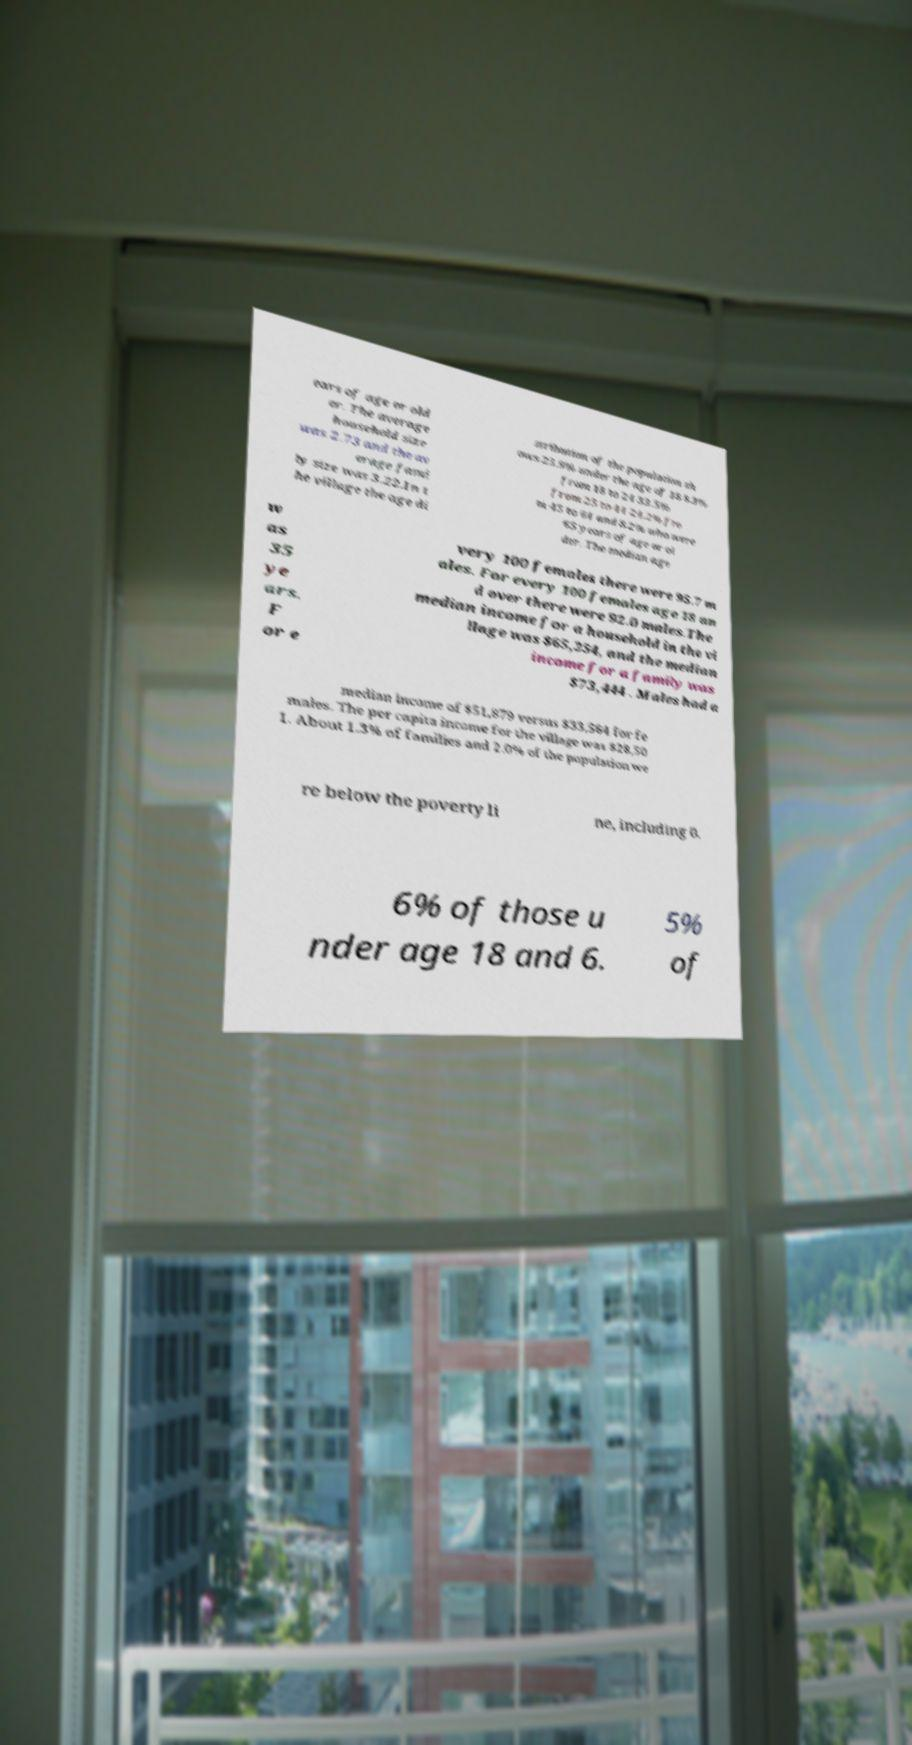Could you assist in decoding the text presented in this image and type it out clearly? ears of age or old er. The average household size was 2.73 and the av erage fami ly size was 3.22.In t he village the age di stribution of the population sh ows 25.9% under the age of 18 8.3% from 18 to 24 33.5% from 25 to 44 24.2% fro m 45 to 64 and 8.2% who were 65 years of age or ol der. The median age w as 35 ye ars. F or e very 100 females there were 95.7 m ales. For every 100 females age 18 an d over there were 92.0 males.The median income for a household in the vi llage was $65,254, and the median income for a family was $73,444 . Males had a median income of $51,879 versus $33,564 for fe males. The per capita income for the village was $28,50 1. About 1.3% of families and 2.0% of the population we re below the poverty li ne, including 0. 6% of those u nder age 18 and 6. 5% of 